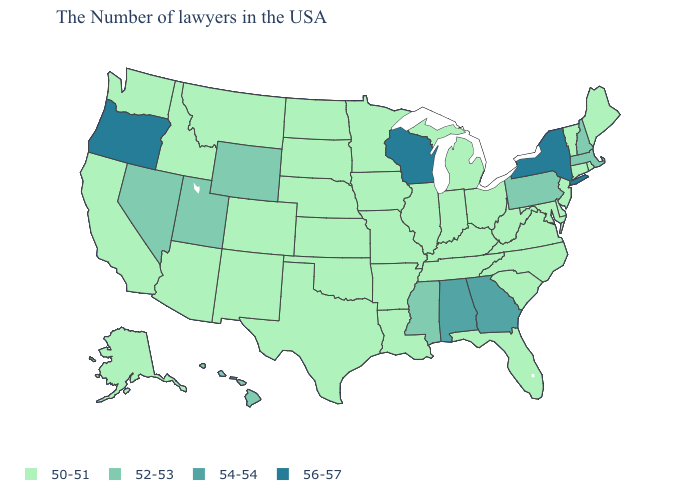Does the first symbol in the legend represent the smallest category?
Concise answer only. Yes. What is the lowest value in the USA?
Short answer required. 50-51. Name the states that have a value in the range 50-51?
Give a very brief answer. Maine, Rhode Island, Vermont, Connecticut, New Jersey, Delaware, Maryland, Virginia, North Carolina, South Carolina, West Virginia, Ohio, Florida, Michigan, Kentucky, Indiana, Tennessee, Illinois, Louisiana, Missouri, Arkansas, Minnesota, Iowa, Kansas, Nebraska, Oklahoma, Texas, South Dakota, North Dakota, Colorado, New Mexico, Montana, Arizona, Idaho, California, Washington, Alaska. Does Vermont have a lower value than Nevada?
Short answer required. Yes. Does the first symbol in the legend represent the smallest category?
Give a very brief answer. Yes. Which states hav the highest value in the South?
Be succinct. Georgia, Alabama. Does New York have the highest value in the USA?
Write a very short answer. Yes. Among the states that border Mississippi , does Arkansas have the lowest value?
Write a very short answer. Yes. Among the states that border Wisconsin , which have the lowest value?
Answer briefly. Michigan, Illinois, Minnesota, Iowa. What is the value of Mississippi?
Write a very short answer. 52-53. Name the states that have a value in the range 54-54?
Write a very short answer. Georgia, Alabama. Among the states that border South Carolina , which have the lowest value?
Be succinct. North Carolina. Among the states that border Nevada , does Oregon have the lowest value?
Write a very short answer. No. What is the highest value in the South ?
Write a very short answer. 54-54. 